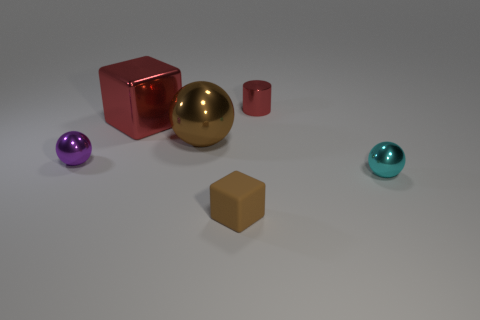Add 4 large red metallic things. How many objects exist? 10 Subtract all cylinders. How many objects are left? 5 Add 1 small cyan rubber cubes. How many small cyan rubber cubes exist? 1 Subtract 0 red spheres. How many objects are left? 6 Subtract all blue cylinders. Subtract all small cylinders. How many objects are left? 5 Add 2 purple spheres. How many purple spheres are left? 3 